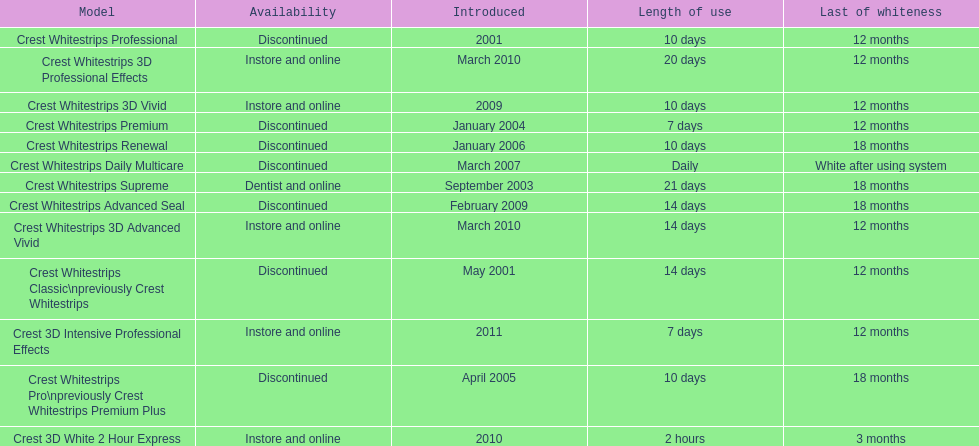What are all of the model names? Crest Whitestrips Classic\npreviously Crest Whitestrips, Crest Whitestrips Professional, Crest Whitestrips Supreme, Crest Whitestrips Premium, Crest Whitestrips Pro\npreviously Crest Whitestrips Premium Plus, Crest Whitestrips Renewal, Crest Whitestrips Daily Multicare, Crest Whitestrips Advanced Seal, Crest Whitestrips 3D Vivid, Crest Whitestrips 3D Advanced Vivid, Crest Whitestrips 3D Professional Effects, Crest 3D White 2 Hour Express, Crest 3D Intensive Professional Effects. When were they first introduced? May 2001, 2001, September 2003, January 2004, April 2005, January 2006, March 2007, February 2009, 2009, March 2010, March 2010, 2010, 2011. Along with crest whitestrips 3d advanced vivid, which other model was introduced in march 2010? Crest Whitestrips 3D Professional Effects. 